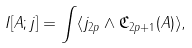<formula> <loc_0><loc_0><loc_500><loc_500>I [ A ; j ] = \int \langle j _ { 2 p } \wedge \mathfrak { C } _ { 2 p + 1 } ( A ) \rangle ,</formula> 